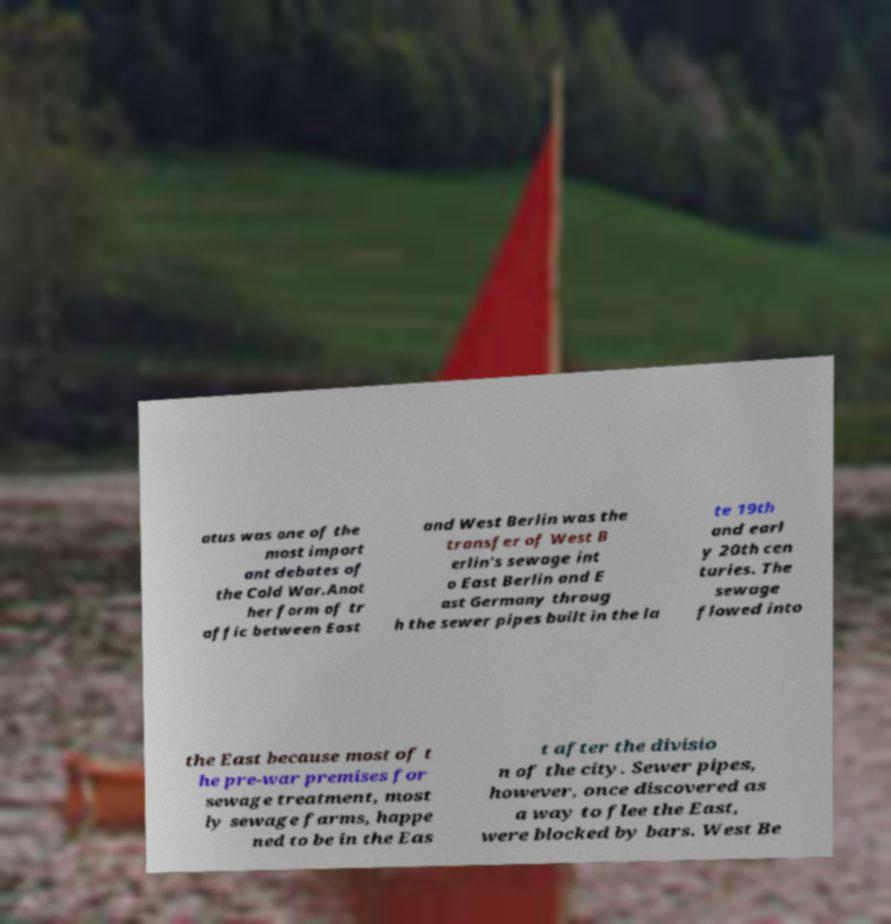Can you accurately transcribe the text from the provided image for me? atus was one of the most import ant debates of the Cold War.Anot her form of tr affic between East and West Berlin was the transfer of West B erlin's sewage int o East Berlin and E ast Germany throug h the sewer pipes built in the la te 19th and earl y 20th cen turies. The sewage flowed into the East because most of t he pre-war premises for sewage treatment, most ly sewage farms, happe ned to be in the Eas t after the divisio n of the city. Sewer pipes, however, once discovered as a way to flee the East, were blocked by bars. West Be 